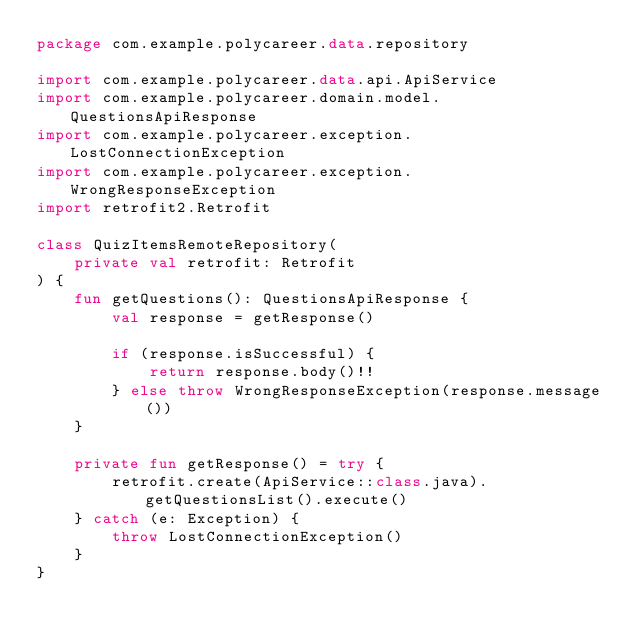Convert code to text. <code><loc_0><loc_0><loc_500><loc_500><_Kotlin_>package com.example.polycareer.data.repository

import com.example.polycareer.data.api.ApiService
import com.example.polycareer.domain.model.QuestionsApiResponse
import com.example.polycareer.exception.LostConnectionException
import com.example.polycareer.exception.WrongResponseException
import retrofit2.Retrofit

class QuizItemsRemoteRepository(
    private val retrofit: Retrofit
) {
    fun getQuestions(): QuestionsApiResponse {
        val response = getResponse()

        if (response.isSuccessful) {
            return response.body()!!
        } else throw WrongResponseException(response.message())
    }

    private fun getResponse() = try {
        retrofit.create(ApiService::class.java).getQuestionsList().execute()
    } catch (e: Exception) {
        throw LostConnectionException()
    }
}</code> 